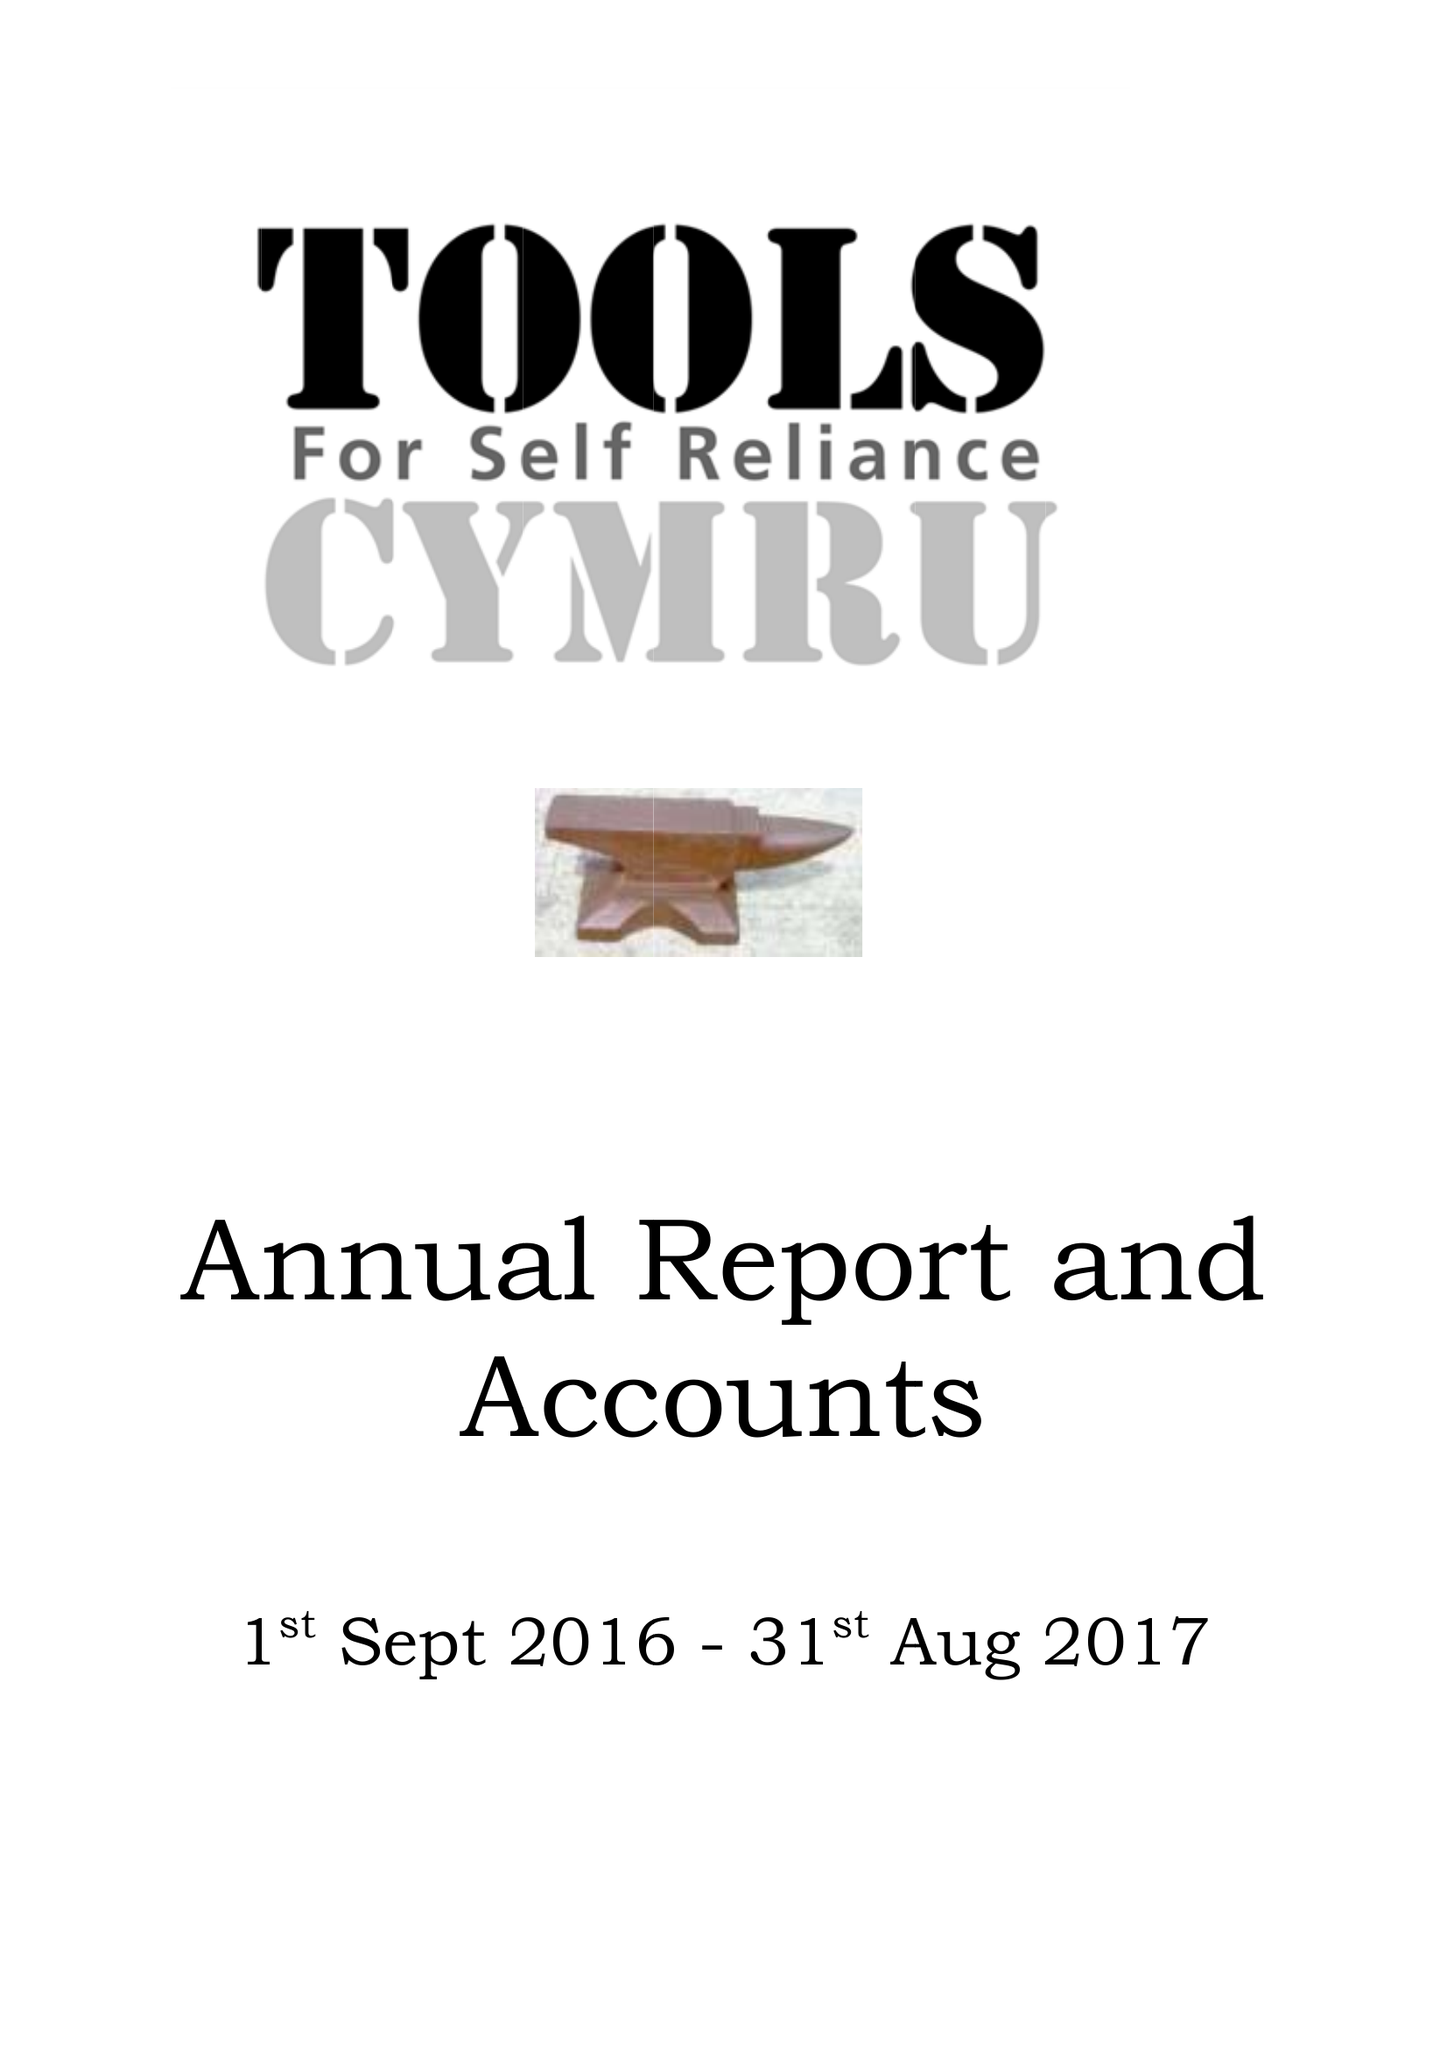What is the value for the income_annually_in_british_pounds?
Answer the question using a single word or phrase. 129033.00 